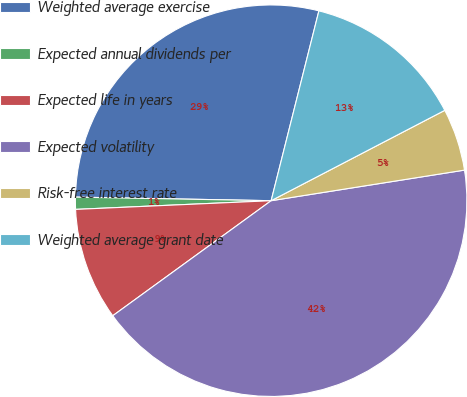<chart> <loc_0><loc_0><loc_500><loc_500><pie_chart><fcel>Weighted average exercise<fcel>Expected annual dividends per<fcel>Expected life in years<fcel>Expected volatility<fcel>Risk-free interest rate<fcel>Weighted average grant date<nl><fcel>28.63%<fcel>1.0%<fcel>9.29%<fcel>42.5%<fcel>5.14%<fcel>13.44%<nl></chart> 